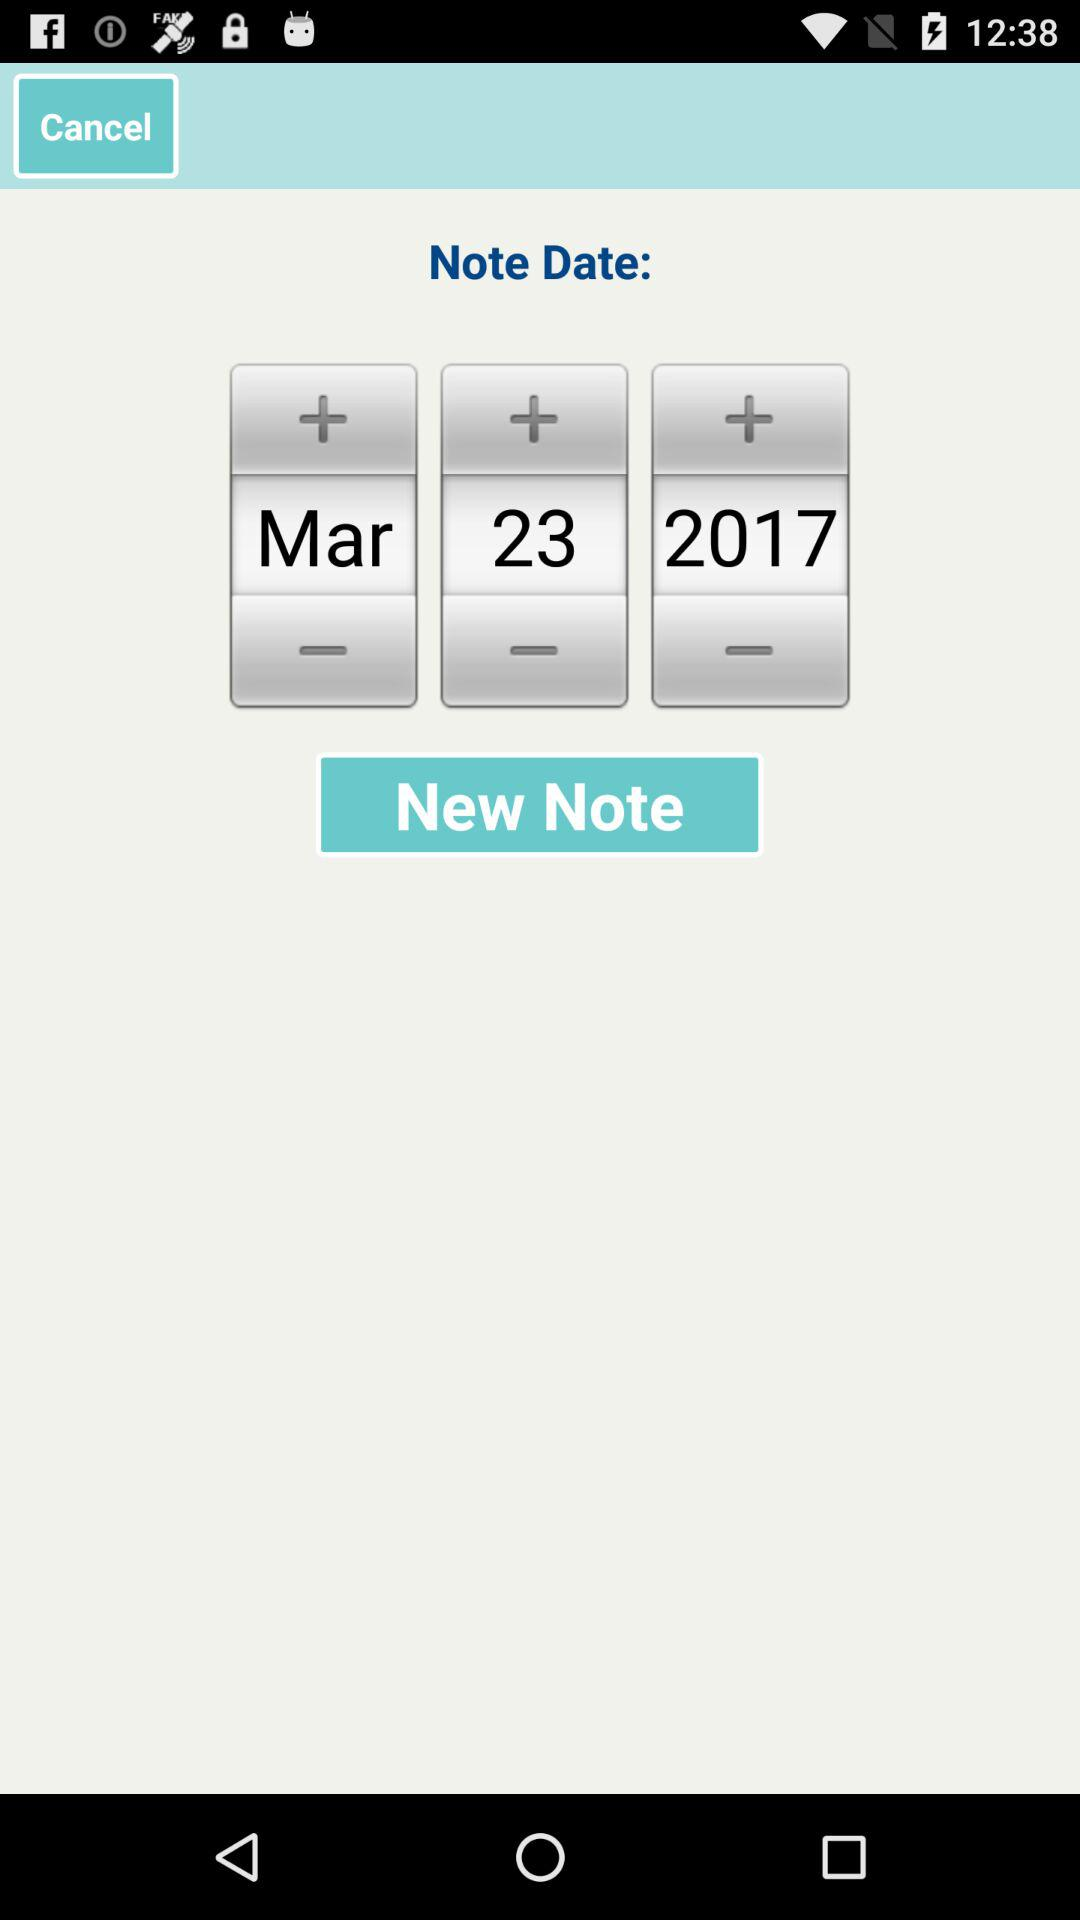How many notes are there?
When the provided information is insufficient, respond with <no answer>. <no answer> 